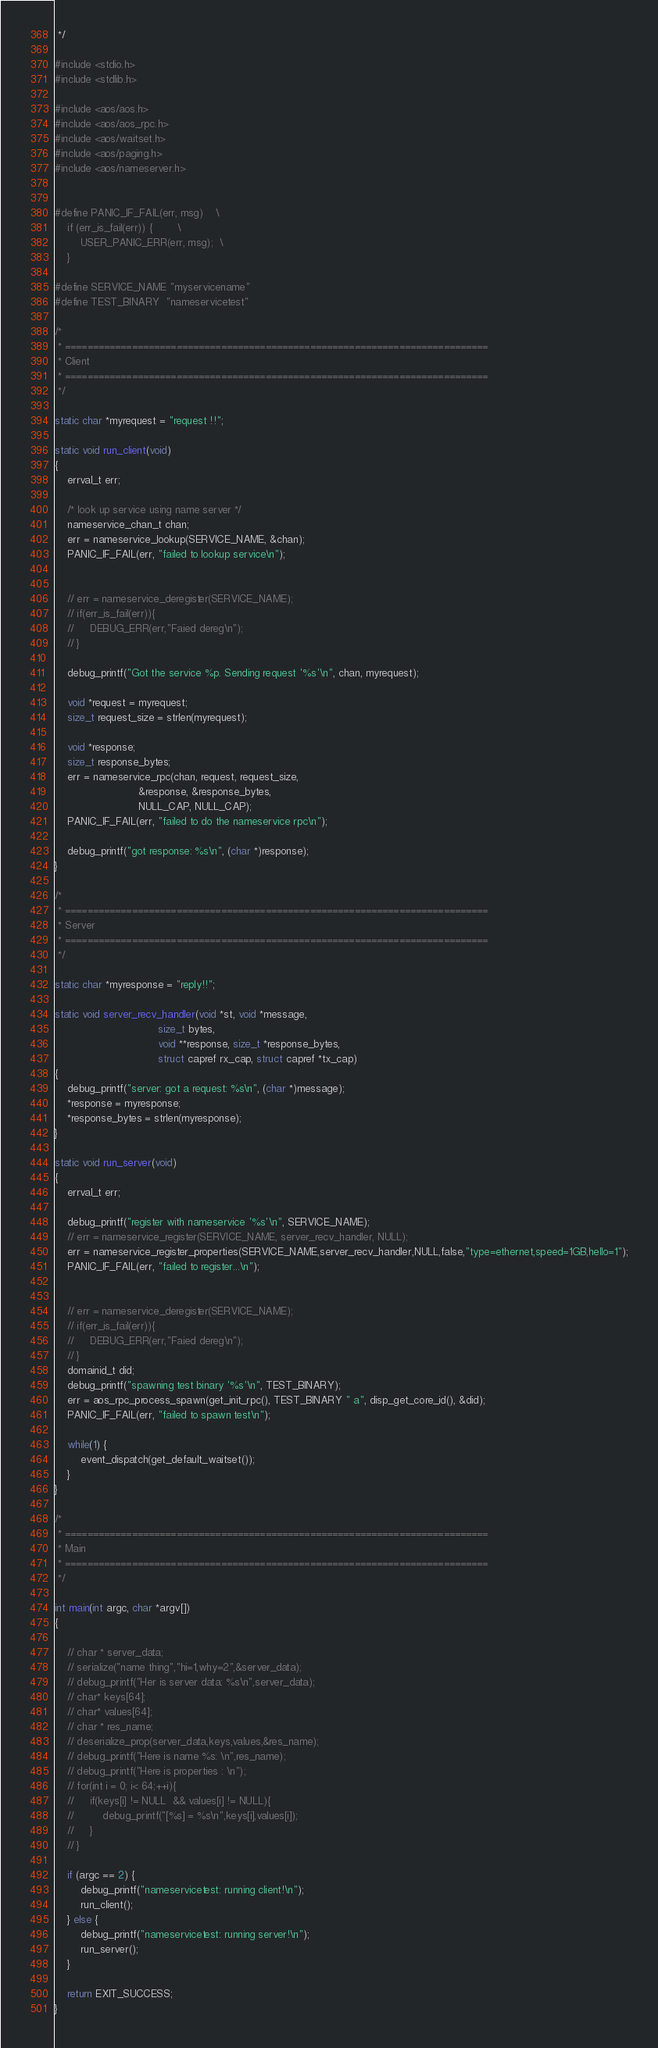Convert code to text. <code><loc_0><loc_0><loc_500><loc_500><_C_> */

#include <stdio.h>
#include <stdlib.h>

#include <aos/aos.h>
#include <aos/aos_rpc.h>
#include <aos/waitset.h>
#include <aos/paging.h>
#include <aos/nameserver.h>


#define PANIC_IF_FAIL(err, msg)    \
    if (err_is_fail(err)) {        \
        USER_PANIC_ERR(err, msg);  \
    }

#define SERVICE_NAME "myservicename"
#define TEST_BINARY  "nameservicetest"

/*
 * ============================================================================
 * Client
 * ============================================================================
 */

static char *myrequest = "request !!";

static void run_client(void)
{
    errval_t err;

    /* look up service using name server */
    nameservice_chan_t chan;
    err = nameservice_lookup(SERVICE_NAME, &chan);
    PANIC_IF_FAIL(err, "failed to lookup service\n");


    // err = nameservice_deregister(SERVICE_NAME);
    // if(err_is_fail(err)){
    //     DEBUG_ERR(err,"Faied dereg\n");
    // }

    debug_printf("Got the service %p. Sending request '%s'\n", chan, myrequest);

    void *request = myrequest;
    size_t request_size = strlen(myrequest);

    void *response;
    size_t response_bytes;
    err = nameservice_rpc(chan, request, request_size,
                          &response, &response_bytes,
                          NULL_CAP, NULL_CAP);
    PANIC_IF_FAIL(err, "failed to do the nameservice rpc\n");

    debug_printf("got response: %s\n", (char *)response);
}

/*
 * ============================================================================
 * Server
 * ============================================================================
 */

static char *myresponse = "reply!!";

static void server_recv_handler(void *st, void *message,
                                size_t bytes,
                                void **response, size_t *response_bytes,
                                struct capref rx_cap, struct capref *tx_cap)
{
    debug_printf("server: got a request: %s\n", (char *)message);
    *response = myresponse;
    *response_bytes = strlen(myresponse);
}

static void run_server(void)
{
    errval_t err;

    debug_printf("register with nameservice '%s'\n", SERVICE_NAME);
    // err = nameservice_register(SERVICE_NAME, server_recv_handler, NULL);
    err = nameservice_register_properties(SERVICE_NAME,server_recv_handler,NULL,false,"type=ethernet,speed=1GB,hello=1");
    PANIC_IF_FAIL(err, "failed to register...\n");


    // err = nameservice_deregister(SERVICE_NAME);
    // if(err_is_fail(err)){
    //     DEBUG_ERR(err,"Faied dereg\n");
    // }
    domainid_t did;
    debug_printf("spawning test binary '%s'\n", TEST_BINARY);
    err = aos_rpc_process_spawn(get_init_rpc(), TEST_BINARY " a", disp_get_core_id(), &did);
    PANIC_IF_FAIL(err, "failed to spawn test\n");

    while(1) {
        event_dispatch(get_default_waitset());
    }
}

/*
 * ============================================================================
 * Main
 * ============================================================================
 */

int main(int argc, char *argv[])
{

    // char * server_data;
    // serialize("name thing","hi=1,why=2",&server_data);
    // debug_printf("Her is server data: %s\n",server_data);
    // char* keys[64];
    // char* values[64];
    // char * res_name;
    // deserialize_prop(server_data,keys,values,&res_name);
    // debug_printf("Here is name %s: \n",res_name);
    // debug_printf("Here is properties : \n");
    // for(int i = 0; i< 64;++i){
    //     if(keys[i] != NULL  && values[i] != NULL){
    //         debug_printf("[%s] = %s\n",keys[i],values[i]);
    //     }
    // }

    if (argc == 2) {
        debug_printf("nameservicetest: running client!\n");
        run_client();
    } else {
        debug_printf("nameservicetest: running server!\n");
        run_server();
    }

    return EXIT_SUCCESS;
}
</code> 